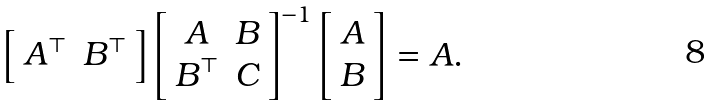Convert formula to latex. <formula><loc_0><loc_0><loc_500><loc_500>\left [ \begin{array} { c c } A ^ { \top } & B ^ { \top } \end{array} \right ] \left [ \begin{array} { c c } A & B \\ B ^ { \top } & C \end{array} \right ] ^ { - 1 } \left [ \begin{array} { c } A \\ B \end{array} \right ] = A .</formula> 